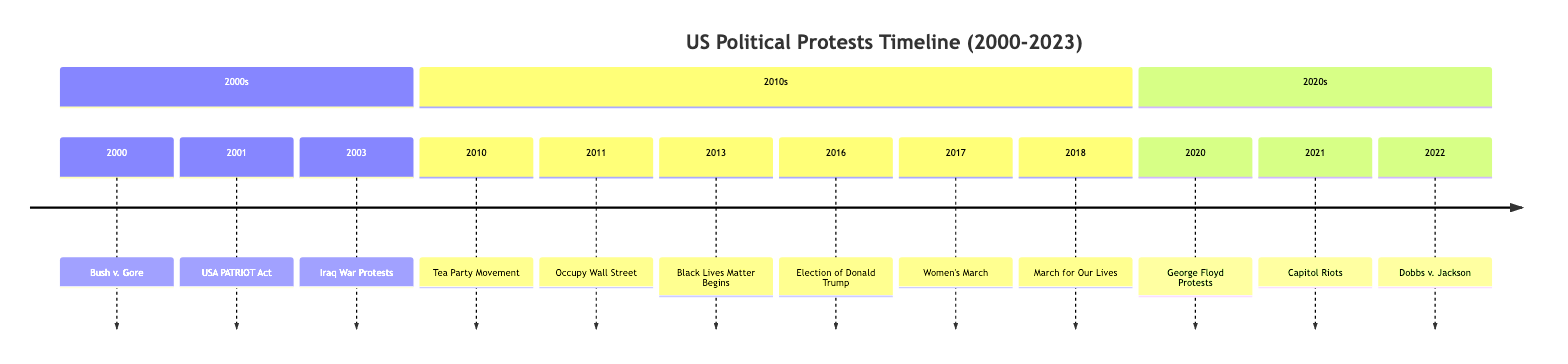What year was the Iraq War Protests? The Iraq War Protests occurred in 2003. This event is clearly labeled in the timeline, making it straightforward to identify the year associated with it.
Answer: 2003 How many major political protests are listed in the timeline from 2000 to 2023? Counting each event listed in the timeline, there are a total of 13 major political protests documented between 2000 and 2023.
Answer: 13 What event is directly connected to the election of Donald Trump? The event directly connected to the election of Donald Trump in 2016 is the widespread protests that followed his election. The timeline notes that this was a contentious presidential election.
Answer: Widespread protests What event occurred immediately after the Black Lives Matter Movement began? The Women's March occurred immediately after the Black Lives Matter Movement began in 2013. The timeline shows these events are sequential.
Answer: Women's March Which event highlights a Supreme Court decision that led to widespread protests in 2022? The Dobbs v. Jackson event highlights the Supreme Court decision that led to protests regarding reproductive rights in 2022. This event is explicitly stated in the timeline.
Answer: Dobbs v. Jackson Name a protest movement focused on economic inequality. The Occupy Wall Street movement is specifically focused on economic inequality and is listed in the timeline under 2011.
Answer: Occupy Wall Street How many events in the timeline correspond to actions or responses to police violence? There are three events in the timeline that correspond to actions or responses to police violence: the Black Lives Matter Movement in 2013, the George Floyd Protests in 2020, and the Women's March in 2017, which also addressed human rights broadly, including police violence.
Answer: 3 What year did the Women's March take place? The Women's March took place in 2017, as indicated in the timeline, which clearly shows the year alongside the event.
Answer: 2017 Which event marked a violent incident related to the political unrest? The Capitol Riots in 2021 marked a violent incident related to political unrest as described in the timeline.
Answer: Capitol Riots 